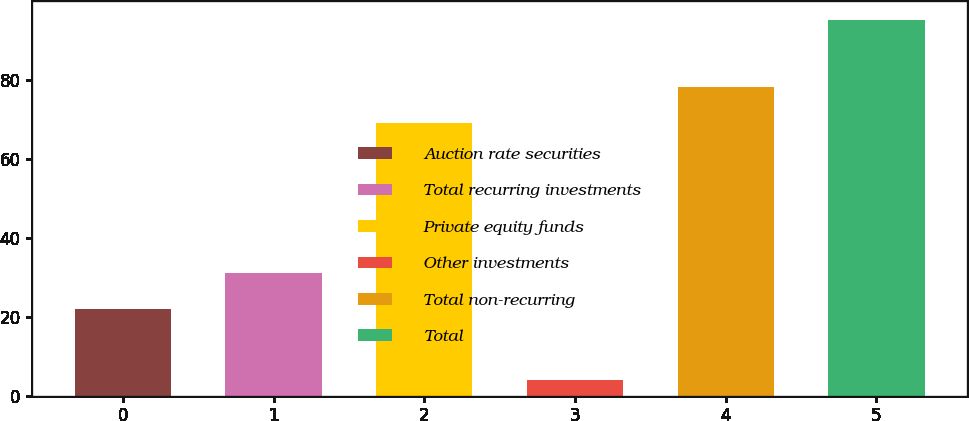<chart> <loc_0><loc_0><loc_500><loc_500><bar_chart><fcel>Auction rate securities<fcel>Total recurring investments<fcel>Private equity funds<fcel>Other investments<fcel>Total non-recurring<fcel>Total<nl><fcel>22<fcel>31.1<fcel>69<fcel>4<fcel>78.1<fcel>95<nl></chart> 